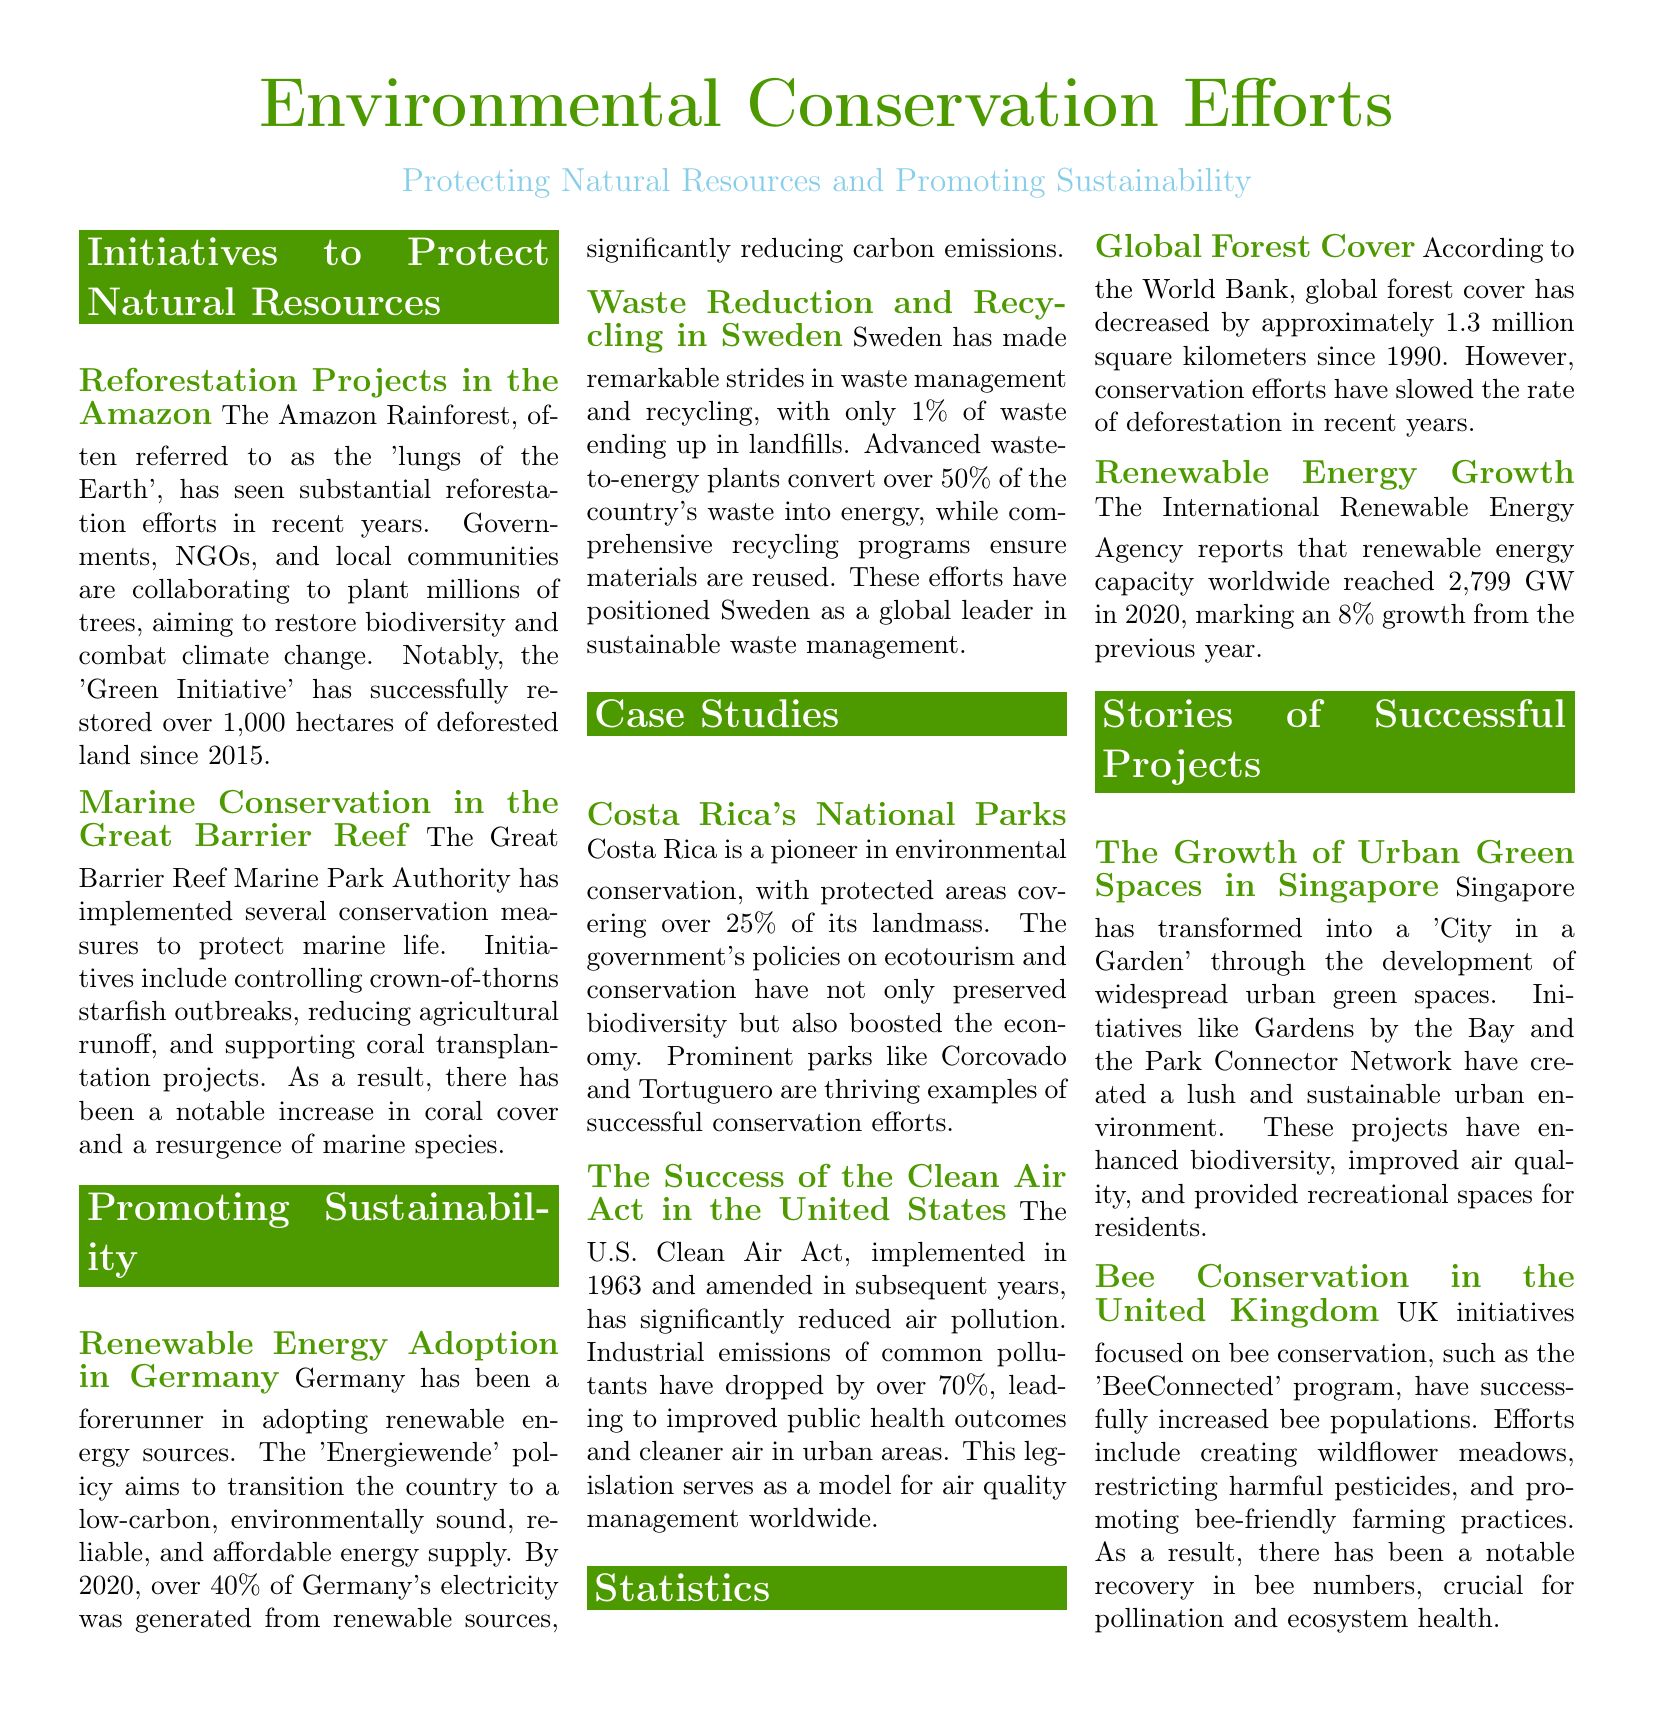what is the name of the initiative restoring deforested land in the Amazon? The initiative focused on restoring deforested land in the Amazon is called the 'Green Initiative'.
Answer: 'Green Initiative' how many hectares of land has the 'Green Initiative' restored since 2015? The 'Green Initiative' has successfully restored over 1,000 hectares of deforested land since 2015.
Answer: over 1,000 hectares what percentage of Germany's electricity came from renewable sources by 2020? By 2020, over 40% of Germany's electricity was generated from renewable sources.
Answer: over 40% which country leads in sustainable waste management with only 1% of waste ending up in landfills? Sweden has made remarkable strides in waste management, with only 1% of waste ending up in landfills.
Answer: Sweden what is the protected area coverage of Costa Rica in terms of its landmass? Protected areas in Costa Rica cover over 25% of its landmass.
Answer: over 25% what significant drop in pollutants has the Clean Air Act achieved? The Clean Air Act has led to a reduction of over 70% in industrial emissions of common pollutants.
Answer: over 70% which program in the UK has focused on increasing bee populations? The 'BeeConnected' program in the UK has successfully increased bee populations.
Answer: 'BeeConnected' what was the renewable energy capacity growth reported in 2020? The renewable energy capacity worldwide reached 2,799 GW in 2020, marking an 8% growth.
Answer: 2,799 GW 